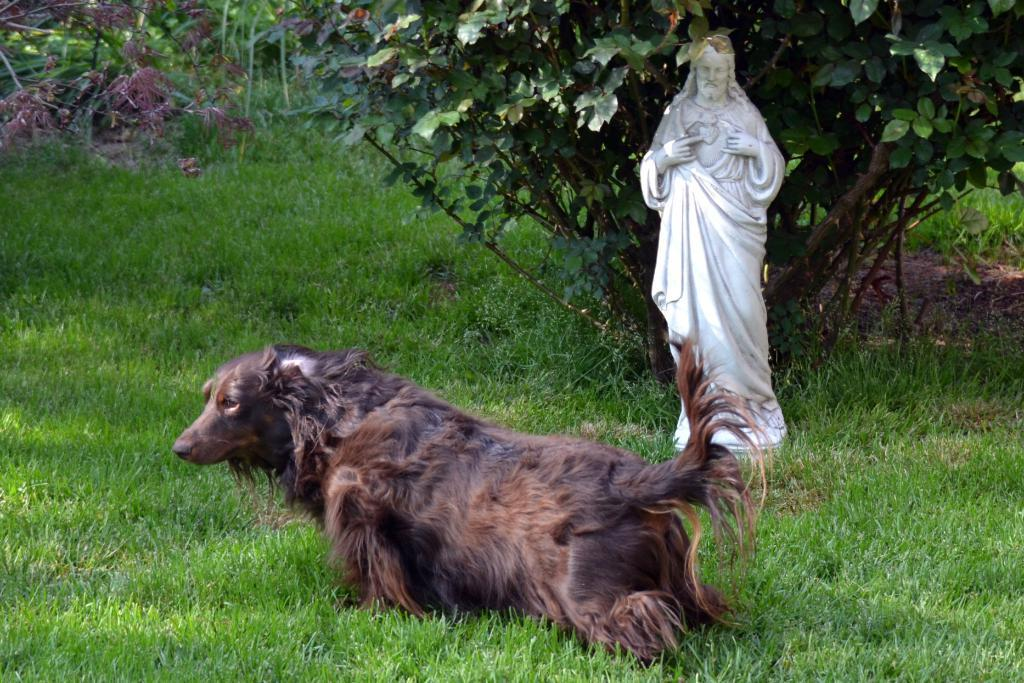What type of animal can be seen in the image? There is a dog in the image. What is located on the grass in the image? There is a statue on the grass. What can be seen in the background of the image? Trees are visible in the background of the image. What flavor of ice cream does the dog prefer in the image? There is no mention of ice cream or any preference for flavor in the image. 